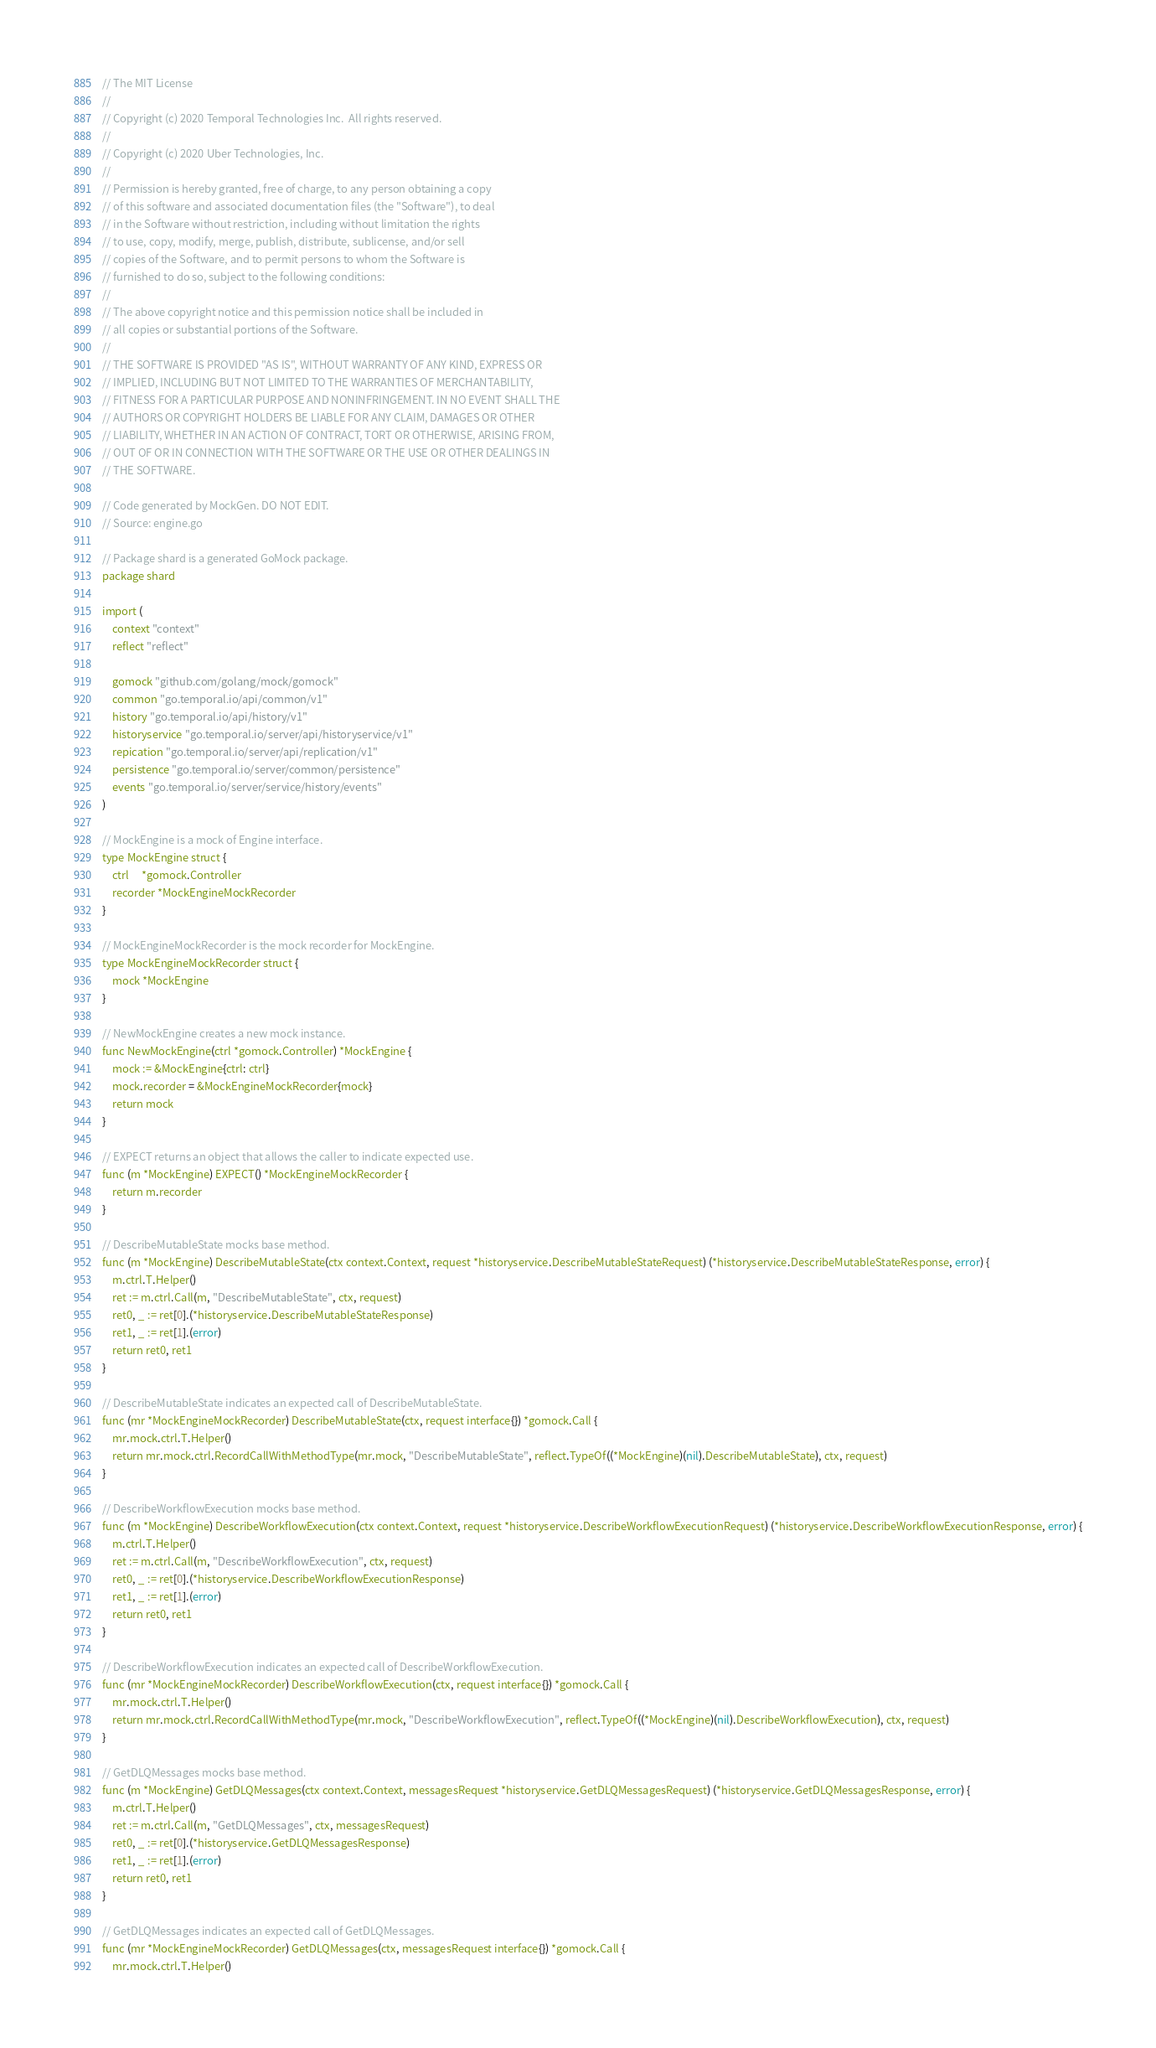Convert code to text. <code><loc_0><loc_0><loc_500><loc_500><_Go_>// The MIT License
//
// Copyright (c) 2020 Temporal Technologies Inc.  All rights reserved.
//
// Copyright (c) 2020 Uber Technologies, Inc.
//
// Permission is hereby granted, free of charge, to any person obtaining a copy
// of this software and associated documentation files (the "Software"), to deal
// in the Software without restriction, including without limitation the rights
// to use, copy, modify, merge, publish, distribute, sublicense, and/or sell
// copies of the Software, and to permit persons to whom the Software is
// furnished to do so, subject to the following conditions:
//
// The above copyright notice and this permission notice shall be included in
// all copies or substantial portions of the Software.
//
// THE SOFTWARE IS PROVIDED "AS IS", WITHOUT WARRANTY OF ANY KIND, EXPRESS OR
// IMPLIED, INCLUDING BUT NOT LIMITED TO THE WARRANTIES OF MERCHANTABILITY,
// FITNESS FOR A PARTICULAR PURPOSE AND NONINFRINGEMENT. IN NO EVENT SHALL THE
// AUTHORS OR COPYRIGHT HOLDERS BE LIABLE FOR ANY CLAIM, DAMAGES OR OTHER
// LIABILITY, WHETHER IN AN ACTION OF CONTRACT, TORT OR OTHERWISE, ARISING FROM,
// OUT OF OR IN CONNECTION WITH THE SOFTWARE OR THE USE OR OTHER DEALINGS IN
// THE SOFTWARE.

// Code generated by MockGen. DO NOT EDIT.
// Source: engine.go

// Package shard is a generated GoMock package.
package shard

import (
	context "context"
	reflect "reflect"

	gomock "github.com/golang/mock/gomock"
	common "go.temporal.io/api/common/v1"
	history "go.temporal.io/api/history/v1"
	historyservice "go.temporal.io/server/api/historyservice/v1"
	repication "go.temporal.io/server/api/replication/v1"
	persistence "go.temporal.io/server/common/persistence"
	events "go.temporal.io/server/service/history/events"
)

// MockEngine is a mock of Engine interface.
type MockEngine struct {
	ctrl     *gomock.Controller
	recorder *MockEngineMockRecorder
}

// MockEngineMockRecorder is the mock recorder for MockEngine.
type MockEngineMockRecorder struct {
	mock *MockEngine
}

// NewMockEngine creates a new mock instance.
func NewMockEngine(ctrl *gomock.Controller) *MockEngine {
	mock := &MockEngine{ctrl: ctrl}
	mock.recorder = &MockEngineMockRecorder{mock}
	return mock
}

// EXPECT returns an object that allows the caller to indicate expected use.
func (m *MockEngine) EXPECT() *MockEngineMockRecorder {
	return m.recorder
}

// DescribeMutableState mocks base method.
func (m *MockEngine) DescribeMutableState(ctx context.Context, request *historyservice.DescribeMutableStateRequest) (*historyservice.DescribeMutableStateResponse, error) {
	m.ctrl.T.Helper()
	ret := m.ctrl.Call(m, "DescribeMutableState", ctx, request)
	ret0, _ := ret[0].(*historyservice.DescribeMutableStateResponse)
	ret1, _ := ret[1].(error)
	return ret0, ret1
}

// DescribeMutableState indicates an expected call of DescribeMutableState.
func (mr *MockEngineMockRecorder) DescribeMutableState(ctx, request interface{}) *gomock.Call {
	mr.mock.ctrl.T.Helper()
	return mr.mock.ctrl.RecordCallWithMethodType(mr.mock, "DescribeMutableState", reflect.TypeOf((*MockEngine)(nil).DescribeMutableState), ctx, request)
}

// DescribeWorkflowExecution mocks base method.
func (m *MockEngine) DescribeWorkflowExecution(ctx context.Context, request *historyservice.DescribeWorkflowExecutionRequest) (*historyservice.DescribeWorkflowExecutionResponse, error) {
	m.ctrl.T.Helper()
	ret := m.ctrl.Call(m, "DescribeWorkflowExecution", ctx, request)
	ret0, _ := ret[0].(*historyservice.DescribeWorkflowExecutionResponse)
	ret1, _ := ret[1].(error)
	return ret0, ret1
}

// DescribeWorkflowExecution indicates an expected call of DescribeWorkflowExecution.
func (mr *MockEngineMockRecorder) DescribeWorkflowExecution(ctx, request interface{}) *gomock.Call {
	mr.mock.ctrl.T.Helper()
	return mr.mock.ctrl.RecordCallWithMethodType(mr.mock, "DescribeWorkflowExecution", reflect.TypeOf((*MockEngine)(nil).DescribeWorkflowExecution), ctx, request)
}

// GetDLQMessages mocks base method.
func (m *MockEngine) GetDLQMessages(ctx context.Context, messagesRequest *historyservice.GetDLQMessagesRequest) (*historyservice.GetDLQMessagesResponse, error) {
	m.ctrl.T.Helper()
	ret := m.ctrl.Call(m, "GetDLQMessages", ctx, messagesRequest)
	ret0, _ := ret[0].(*historyservice.GetDLQMessagesResponse)
	ret1, _ := ret[1].(error)
	return ret0, ret1
}

// GetDLQMessages indicates an expected call of GetDLQMessages.
func (mr *MockEngineMockRecorder) GetDLQMessages(ctx, messagesRequest interface{}) *gomock.Call {
	mr.mock.ctrl.T.Helper()</code> 